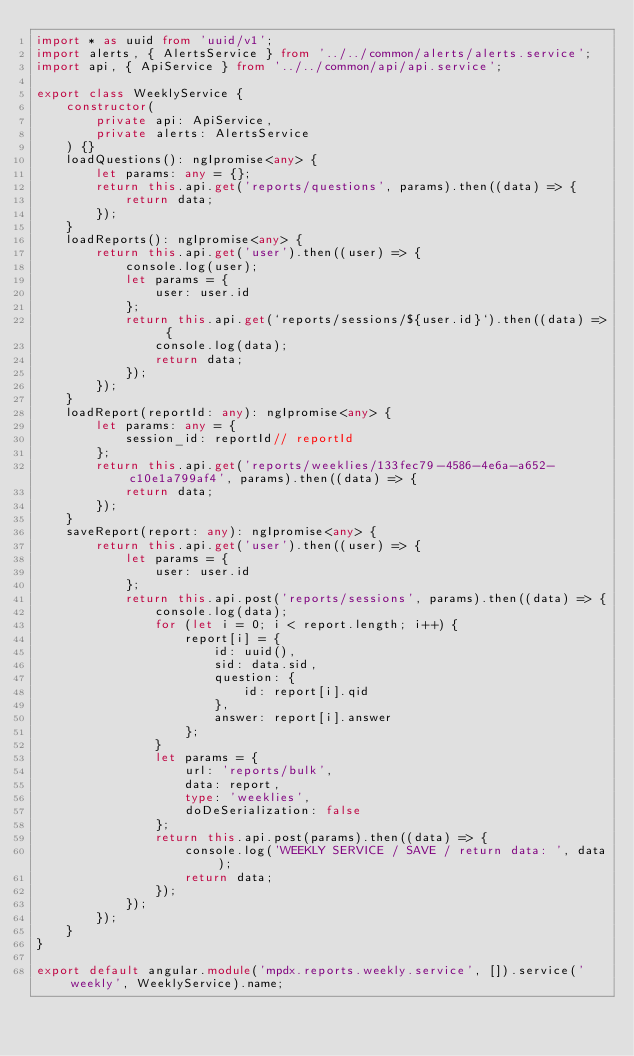<code> <loc_0><loc_0><loc_500><loc_500><_TypeScript_>import * as uuid from 'uuid/v1';
import alerts, { AlertsService } from '../../common/alerts/alerts.service';
import api, { ApiService } from '../../common/api/api.service';

export class WeeklyService {
    constructor(
        private api: ApiService,
        private alerts: AlertsService
    ) {}
    loadQuestions(): ngIpromise<any> {
        let params: any = {};
        return this.api.get('reports/questions', params).then((data) => {
            return data;
        });
    }
    loadReports(): ngIpromise<any> {
        return this.api.get('user').then((user) => {
            console.log(user);
            let params = {
                user: user.id
            };
            return this.api.get(`reports/sessions/${user.id}`).then((data) => {
                console.log(data);
                return data;
            });
        });
    }
    loadReport(reportId: any): ngIpromise<any> {
        let params: any = {
            session_id: reportId// reportId
        };
        return this.api.get('reports/weeklies/133fec79-4586-4e6a-a652-c10e1a799af4', params).then((data) => {
            return data;
        });
    }
    saveReport(report: any): ngIpromise<any> {
        return this.api.get('user').then((user) => {
            let params = {
                user: user.id
            };
            return this.api.post('reports/sessions', params).then((data) => {
                console.log(data);
                for (let i = 0; i < report.length; i++) {
                    report[i] = {
                        id: uuid(),
                        sid: data.sid,
                        question: {
                            id: report[i].qid
                        },
                        answer: report[i].answer
                    };
                }
                let params = {
                    url: 'reports/bulk',
                    data: report,
                    type: 'weeklies',
                    doDeSerialization: false
                };
                return this.api.post(params).then((data) => {
                    console.log('WEEKLY SERVICE / SAVE / return data: ', data);
                    return data;
                });
            });
        });
    }
}

export default angular.module('mpdx.reports.weekly.service', []).service('weekly', WeeklyService).name;
</code> 